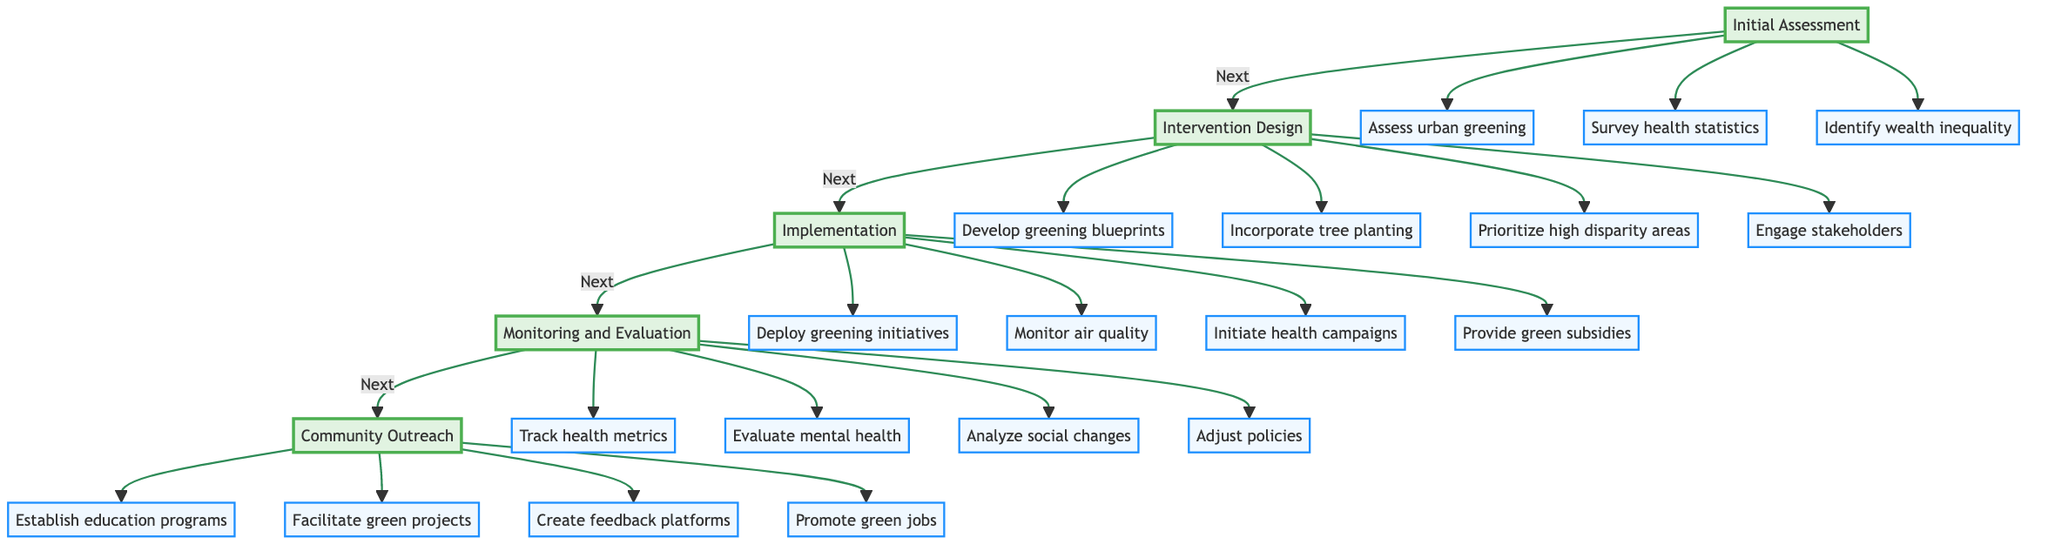What is the first phase in the Clinical Pathway? The diagram indicates that the first phase is "Initial Assessment." This is directly identified at the top of the flowchart and serves as the starting point for the pathway.
Answer: Initial Assessment How many components are in the "Intervention Design" phase? The "Intervention Design" phase is linked to four components: 1) Develop greening blueprints, 2) Incorporate tree planting, 3) Prioritize high disparity areas, and 4) Engage stakeholders. Each of these is connected directly to the "Intervention Design" node.
Answer: Four Name one component of the "Implementation" phase. In the "Implementation" phase, one of the components is "Deploy greening initiatives." This is listed directly under the "Implementation" node.
Answer: Deploy greening initiatives Which phase comes after "Community Outreach"? According to the flow of the diagram, "Community Outreach" is the last phase, and there are no subsequent phases connected to it, indicating it does not lead to further steps.
Answer: None What is the relationship between "Monitoring and Evaluation" and "Implementation"? The diagram shows a sequential relationship; "Implementation" leads to "Monitoring and Evaluation." This means the actions taken in "Implementation" are followed by an evaluation in this next phase.
Answer: Sequential How many total phases are represented in the Clinical Pathway? The diagram displays five distinct phases: 1) Initial Assessment, 2) Intervention Design, 3) Implementation, 4) Monitoring and Evaluation, and 5) Community Outreach. This total is counted visually by identifying each separate phase in the flowchart.
Answer: Five Which component of "Monitoring and Evaluation" focuses on health metrics? "Track health metrics" is the specific component within "Monitoring and Evaluation" that emphasizes public health metrics, such as hospital admissions and asthma rates, clearly linked under that phase.
Answer: Track health metrics What action is suggested under "Community Outreach" aimed at education? The component "Establish education programs" is directly linked under "Community Outreach," indicating the focus on educating the community about the benefits of urban greenery.
Answer: Establish education programs Which component under "Implementation" is related to air quality? "Monitor air quality" is the component under "Implementation" that addresses air quality and temperature variations, emphasizing its importance in the urban greening initiatives.
Answer: Monitor air quality 